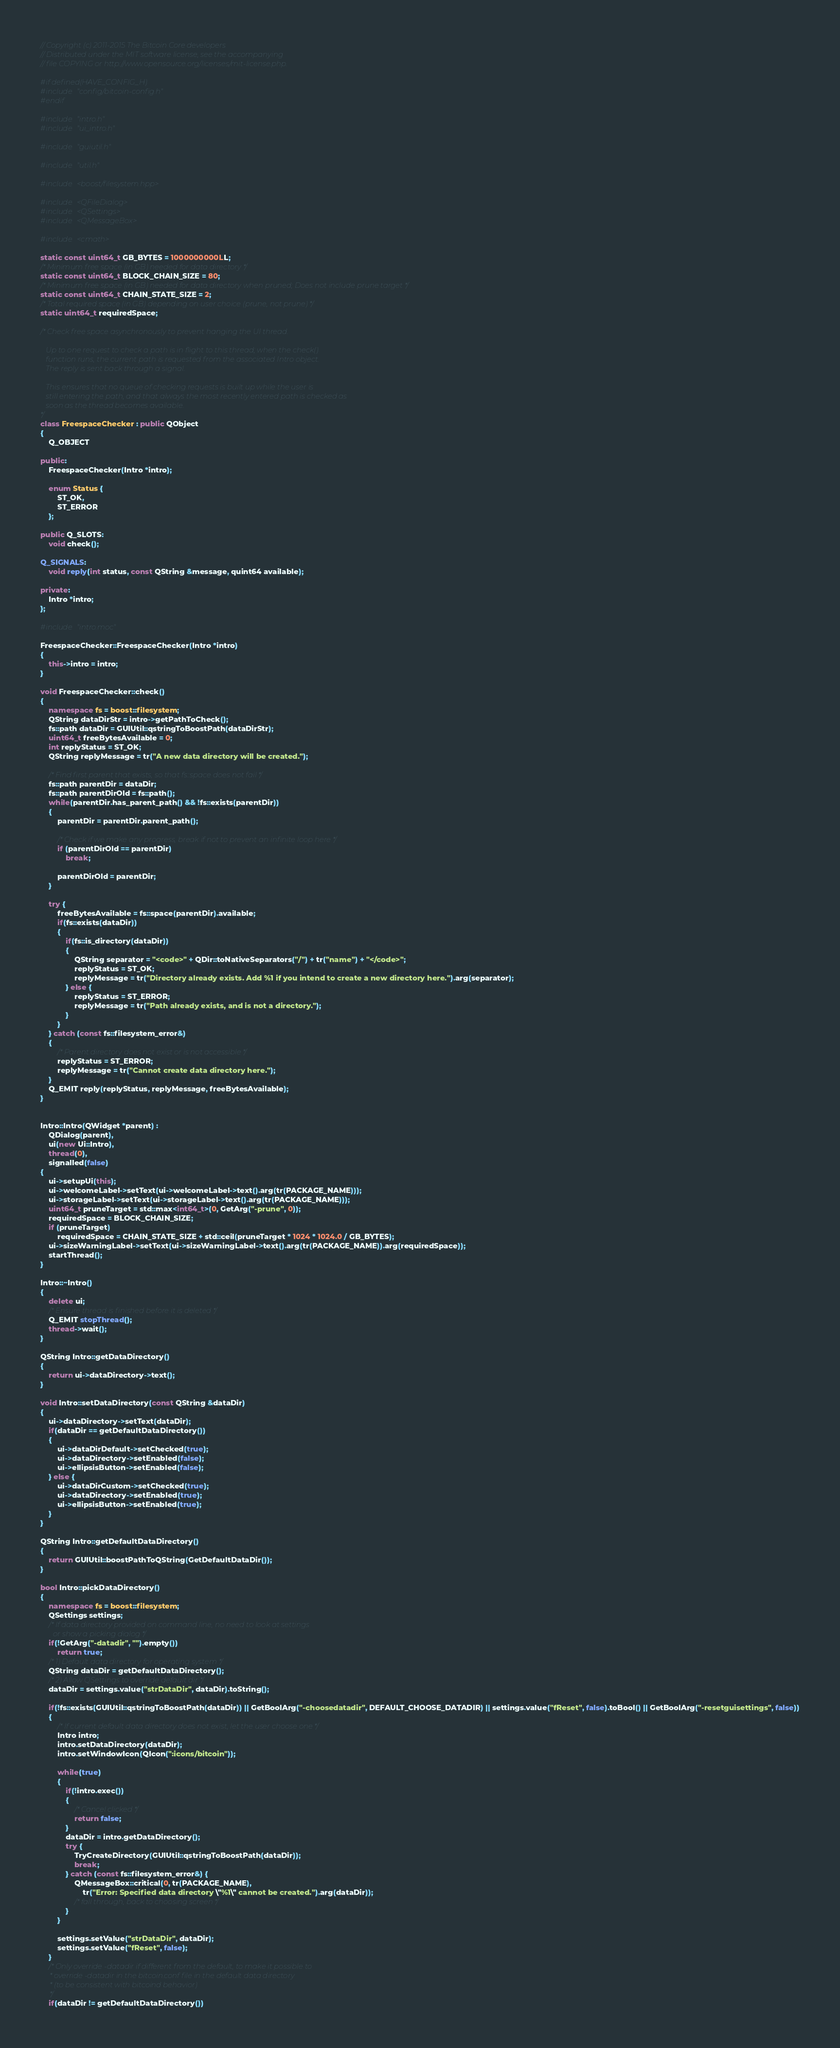<code> <loc_0><loc_0><loc_500><loc_500><_C++_>// Copyright (c) 2011-2015 The Bitcoin Core developers
// Distributed under the MIT software license, see the accompanying
// file COPYING or http://www.opensource.org/licenses/mit-license.php.

#if defined(HAVE_CONFIG_H)
#include "config/bitcoin-config.h"
#endif

#include "intro.h"
#include "ui_intro.h"

#include "guiutil.h"

#include "util.h"

#include <boost/filesystem.hpp>

#include <QFileDialog>
#include <QSettings>
#include <QMessageBox>

#include <cmath>

static const uint64_t GB_BYTES = 1000000000LL;
/* Minimum free space (in GB) needed for data directory */
static const uint64_t BLOCK_CHAIN_SIZE = 80;
/* Minimum free space (in GB) needed for data directory when pruned; Does not include prune target */
static const uint64_t CHAIN_STATE_SIZE = 2;
/* Total required space (in GB) depending on user choice (prune, not prune) */
static uint64_t requiredSpace;

/* Check free space asynchronously to prevent hanging the UI thread.

   Up to one request to check a path is in flight to this thread; when the check()
   function runs, the current path is requested from the associated Intro object.
   The reply is sent back through a signal.

   This ensures that no queue of checking requests is built up while the user is
   still entering the path, and that always the most recently entered path is checked as
   soon as the thread becomes available.
*/
class FreespaceChecker : public QObject
{
    Q_OBJECT

public:
    FreespaceChecker(Intro *intro);

    enum Status {
        ST_OK,
        ST_ERROR
    };

public Q_SLOTS:
    void check();

Q_SIGNALS:
    void reply(int status, const QString &message, quint64 available);

private:
    Intro *intro;
};

#include "intro.moc"

FreespaceChecker::FreespaceChecker(Intro *intro)
{
    this->intro = intro;
}

void FreespaceChecker::check()
{
    namespace fs = boost::filesystem;
    QString dataDirStr = intro->getPathToCheck();
    fs::path dataDir = GUIUtil::qstringToBoostPath(dataDirStr);
    uint64_t freeBytesAvailable = 0;
    int replyStatus = ST_OK;
    QString replyMessage = tr("A new data directory will be created.");

    /* Find first parent that exists, so that fs::space does not fail */
    fs::path parentDir = dataDir;
    fs::path parentDirOld = fs::path();
    while(parentDir.has_parent_path() && !fs::exists(parentDir))
    {
        parentDir = parentDir.parent_path();

        /* Check if we make any progress, break if not to prevent an infinite loop here */
        if (parentDirOld == parentDir)
            break;

        parentDirOld = parentDir;
    }

    try {
        freeBytesAvailable = fs::space(parentDir).available;
        if(fs::exists(dataDir))
        {
            if(fs::is_directory(dataDir))
            {
                QString separator = "<code>" + QDir::toNativeSeparators("/") + tr("name") + "</code>";
                replyStatus = ST_OK;
                replyMessage = tr("Directory already exists. Add %1 if you intend to create a new directory here.").arg(separator);
            } else {
                replyStatus = ST_ERROR;
                replyMessage = tr("Path already exists, and is not a directory.");
            }
        }
    } catch (const fs::filesystem_error&)
    {
        /* Parent directory does not exist or is not accessible */
        replyStatus = ST_ERROR;
        replyMessage = tr("Cannot create data directory here.");
    }
    Q_EMIT reply(replyStatus, replyMessage, freeBytesAvailable);
}


Intro::Intro(QWidget *parent) :
    QDialog(parent),
    ui(new Ui::Intro),
    thread(0),
    signalled(false)
{
    ui->setupUi(this);
    ui->welcomeLabel->setText(ui->welcomeLabel->text().arg(tr(PACKAGE_NAME)));
    ui->storageLabel->setText(ui->storageLabel->text().arg(tr(PACKAGE_NAME)));
    uint64_t pruneTarget = std::max<int64_t>(0, GetArg("-prune", 0));
    requiredSpace = BLOCK_CHAIN_SIZE;
    if (pruneTarget)
        requiredSpace = CHAIN_STATE_SIZE + std::ceil(pruneTarget * 1024 * 1024.0 / GB_BYTES);
    ui->sizeWarningLabel->setText(ui->sizeWarningLabel->text().arg(tr(PACKAGE_NAME)).arg(requiredSpace));
    startThread();
}

Intro::~Intro()
{
    delete ui;
    /* Ensure thread is finished before it is deleted */
    Q_EMIT stopThread();
    thread->wait();
}

QString Intro::getDataDirectory()
{
    return ui->dataDirectory->text();
}

void Intro::setDataDirectory(const QString &dataDir)
{
    ui->dataDirectory->setText(dataDir);
    if(dataDir == getDefaultDataDirectory())
    {
        ui->dataDirDefault->setChecked(true);
        ui->dataDirectory->setEnabled(false);
        ui->ellipsisButton->setEnabled(false);
    } else {
        ui->dataDirCustom->setChecked(true);
        ui->dataDirectory->setEnabled(true);
        ui->ellipsisButton->setEnabled(true);
    }
}

QString Intro::getDefaultDataDirectory()
{
    return GUIUtil::boostPathToQString(GetDefaultDataDir());
}

bool Intro::pickDataDirectory()
{
    namespace fs = boost::filesystem;
    QSettings settings;
    /* If data directory provided on command line, no need to look at settings
       or show a picking dialog */
    if(!GetArg("-datadir", "").empty())
        return true;
    /* 1) Default data directory for operating system */
    QString dataDir = getDefaultDataDirectory();
    /* 2) Allow QSettings to override default dir */
    dataDir = settings.value("strDataDir", dataDir).toString();

    if(!fs::exists(GUIUtil::qstringToBoostPath(dataDir)) || GetBoolArg("-choosedatadir", DEFAULT_CHOOSE_DATADIR) || settings.value("fReset", false).toBool() || GetBoolArg("-resetguisettings", false))
    {
        /* If current default data directory does not exist, let the user choose one */
        Intro intro;
        intro.setDataDirectory(dataDir);
        intro.setWindowIcon(QIcon(":icons/bitcoin"));

        while(true)
        {
            if(!intro.exec())
            {
                /* Cancel clicked */
                return false;
            }
            dataDir = intro.getDataDirectory();
            try {
                TryCreateDirectory(GUIUtil::qstringToBoostPath(dataDir));
                break;
            } catch (const fs::filesystem_error&) {
                QMessageBox::critical(0, tr(PACKAGE_NAME),
                    tr("Error: Specified data directory \"%1\" cannot be created.").arg(dataDir));
                /* fall through, back to choosing screen */
            }
        }

        settings.setValue("strDataDir", dataDir);
        settings.setValue("fReset", false);
    }
    /* Only override -datadir if different from the default, to make it possible to
     * override -datadir in the bitcoin.conf file in the default data directory
     * (to be consistent with bitcoind behavior)
     */
    if(dataDir != getDefaultDataDirectory())</code> 